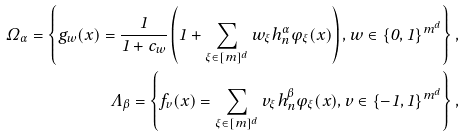<formula> <loc_0><loc_0><loc_500><loc_500>\Omega _ { \alpha } = \left \{ g _ { w } ( x ) = \frac { 1 } { 1 + c _ { w } } \left ( 1 + \sum _ { \xi \in [ m ] ^ { d } } w _ { \xi } h _ { n } ^ { \alpha } \varphi _ { \xi } ( x ) \right ) , w \in \{ 0 , 1 \} ^ { m ^ { d } } \right \} , \\ \Lambda _ { \beta } = \left \{ f _ { v } ( x ) = \sum _ { \xi \in [ m ] ^ { d } } v _ { \xi } h _ { n } ^ { \beta } \varphi _ { \xi } ( x ) , v \in \{ - 1 , 1 \} ^ { m ^ { d } } \right \} ,</formula> 